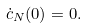<formula> <loc_0><loc_0><loc_500><loc_500>\dot { c } _ { N } ( 0 ) = 0 .</formula> 